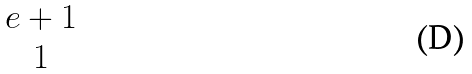<formula> <loc_0><loc_0><loc_500><loc_500>\begin{matrix} e + 1 \\ 1 \end{matrix}</formula> 